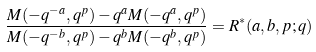<formula> <loc_0><loc_0><loc_500><loc_500>\frac { M ( - q ^ { - a } , q ^ { p } ) - q ^ { a } M ( - q ^ { a } , q ^ { p } ) } { M ( - q ^ { - b } , q ^ { p } ) - q ^ { b } M ( - q ^ { b } , q ^ { p } ) } = R ^ { * } ( a , b , p ; q )</formula> 